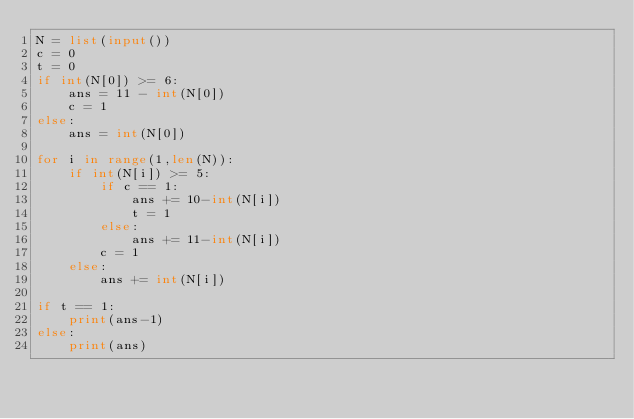<code> <loc_0><loc_0><loc_500><loc_500><_Python_>N = list(input())
c = 0
t = 0
if int(N[0]) >= 6:
    ans = 11 - int(N[0])
    c = 1
else:
    ans = int(N[0])

for i in range(1,len(N)):
    if int(N[i]) >= 5:
        if c == 1:
            ans += 10-int(N[i])
            t = 1
        else:
            ans += 11-int(N[i])
        c = 1
    else:
        ans += int(N[i])

if t == 1:
    print(ans-1)
else:
    print(ans)</code> 